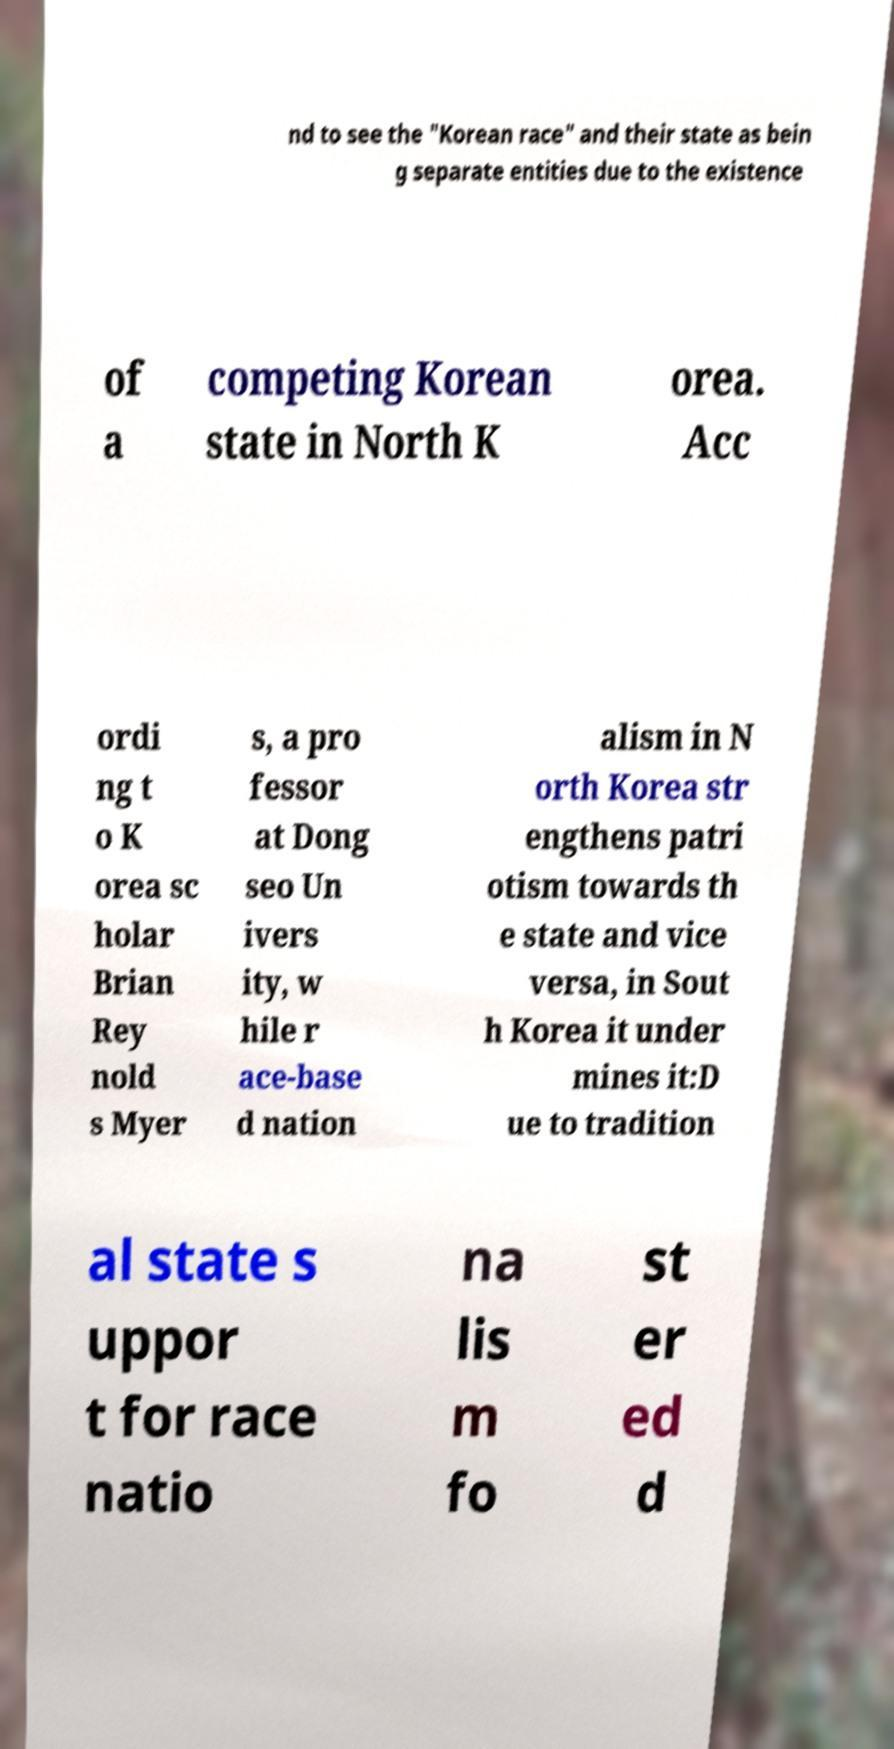Can you accurately transcribe the text from the provided image for me? nd to see the "Korean race" and their state as bein g separate entities due to the existence of a competing Korean state in North K orea. Acc ordi ng t o K orea sc holar Brian Rey nold s Myer s, a pro fessor at Dong seo Un ivers ity, w hile r ace-base d nation alism in N orth Korea str engthens patri otism towards th e state and vice versa, in Sout h Korea it under mines it:D ue to tradition al state s uppor t for race natio na lis m fo st er ed d 